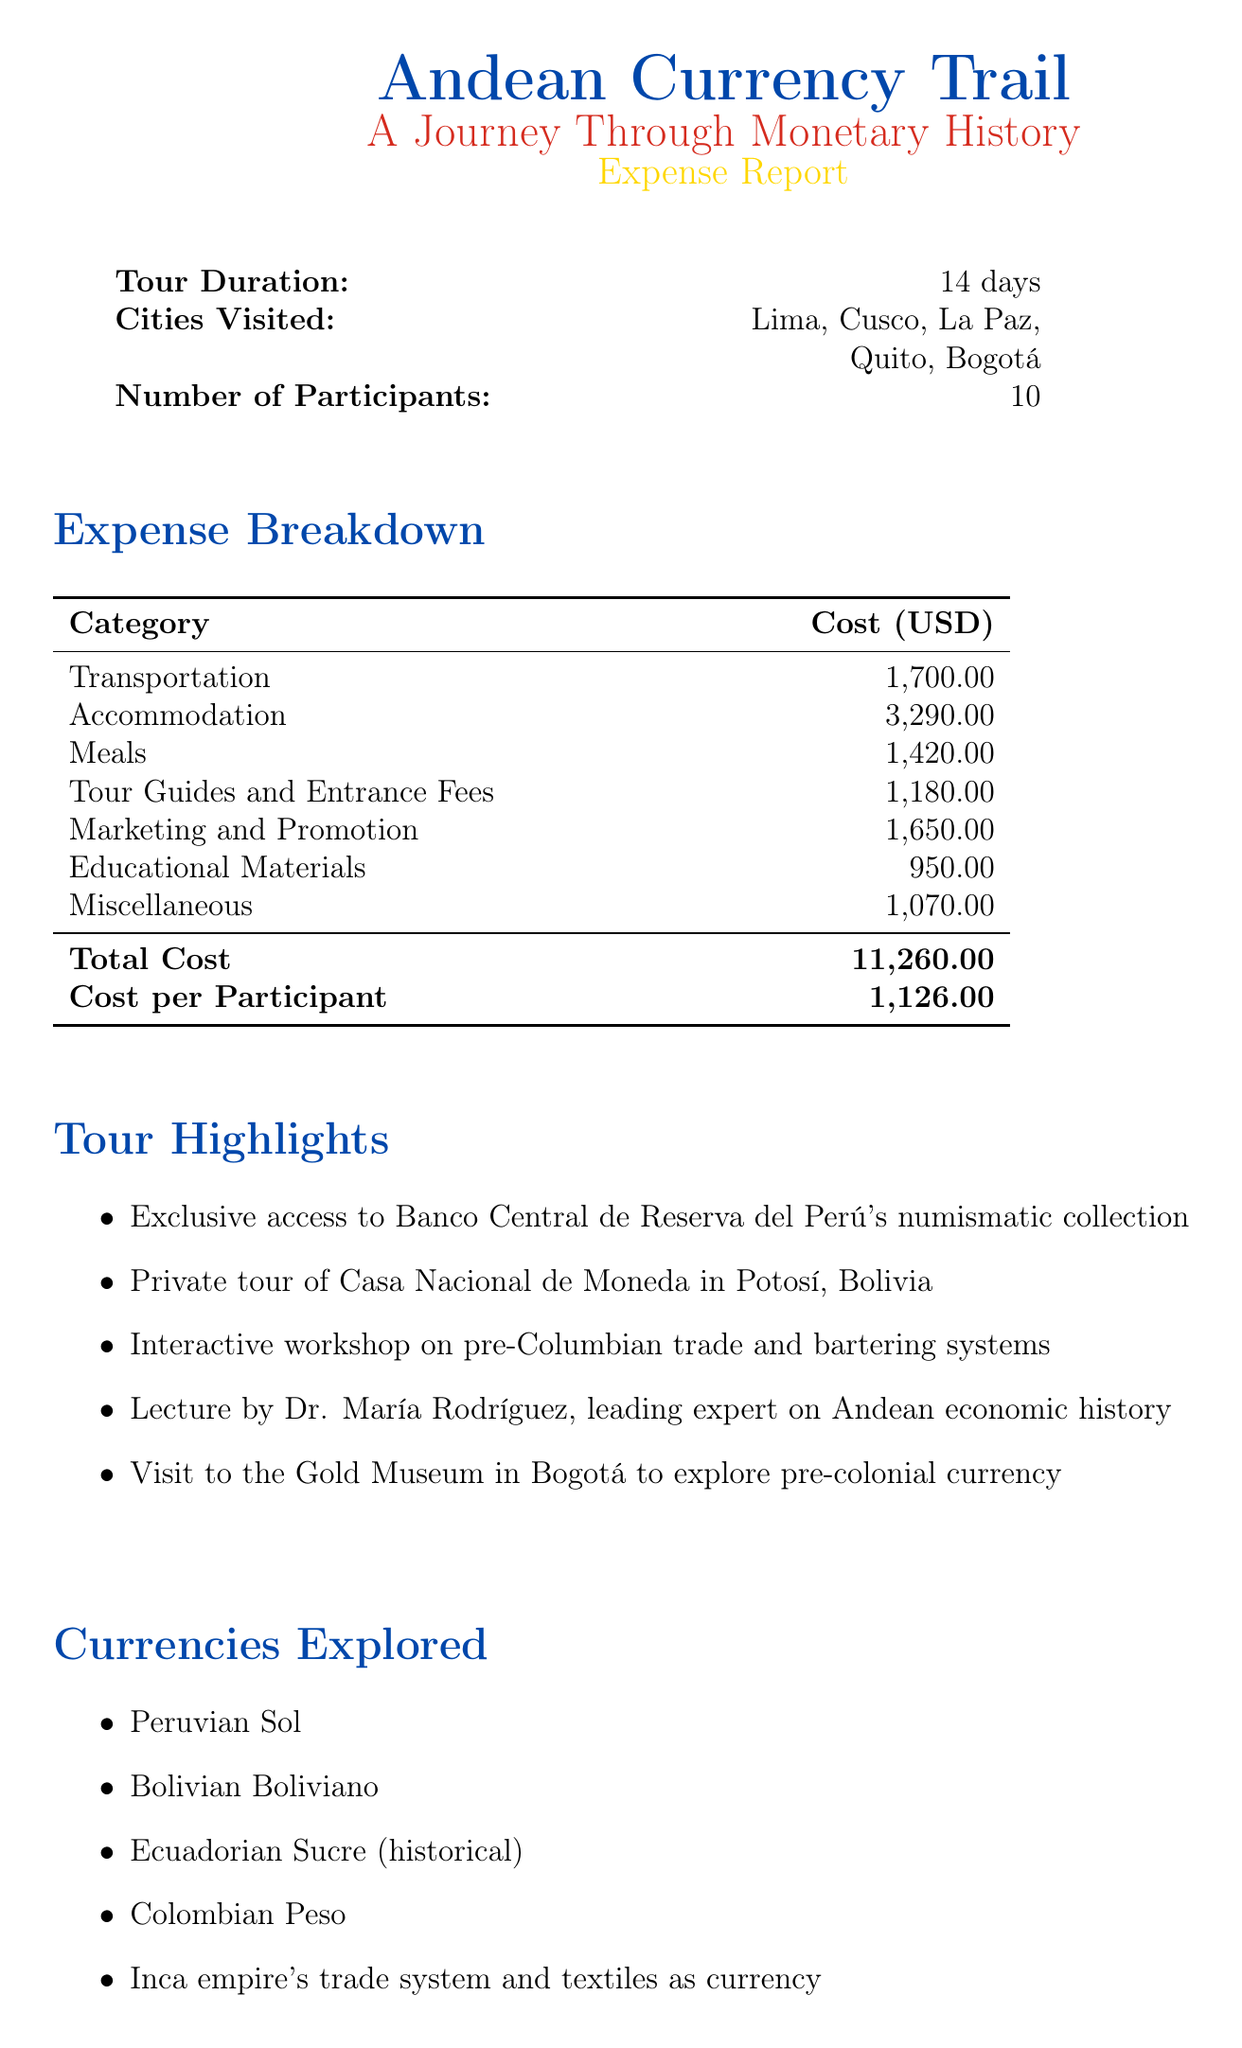what is the total cost of the tour? The total cost is listed at the bottom of the expense breakdown in the document.
Answer: 11,260.00 how many cities are visited during the tour? The number of cities visited is indicated in the overview section of the document.
Answer: 5 what is the cost of local transportation? The cost for local transportation is found in the transportation expense section.
Answer: 300.00 who is the leading expert on Andean economic history? The document mentions Dr. María Rodríguez as the expert during a lecture in the tour highlights section.
Answer: Dr. María Rodríguez what is the cost per participant? The cost per participant is specified in the expense breakdown section at the end of the document.
Answer: 1,126.00 what is one historical currency explored during the tour? The currencies explored are listed, and one currency can be directly referenced from that list.
Answer: Ecuadorian Sucre how much was spent on educational materials? The total cost for educational materials is detailed in the expense breakdown in the document.
Answer: 950.00 what category includes the train ticket cost? The cost for the train ticket is specified under the transportation category in the expenses section.
Answer: Transportation 